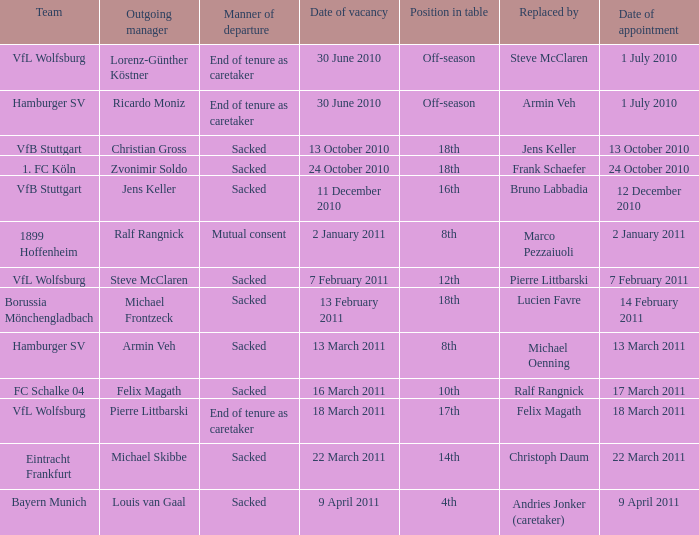What is the appointment date when the team is 1. fc köln? 24 October 2010. 